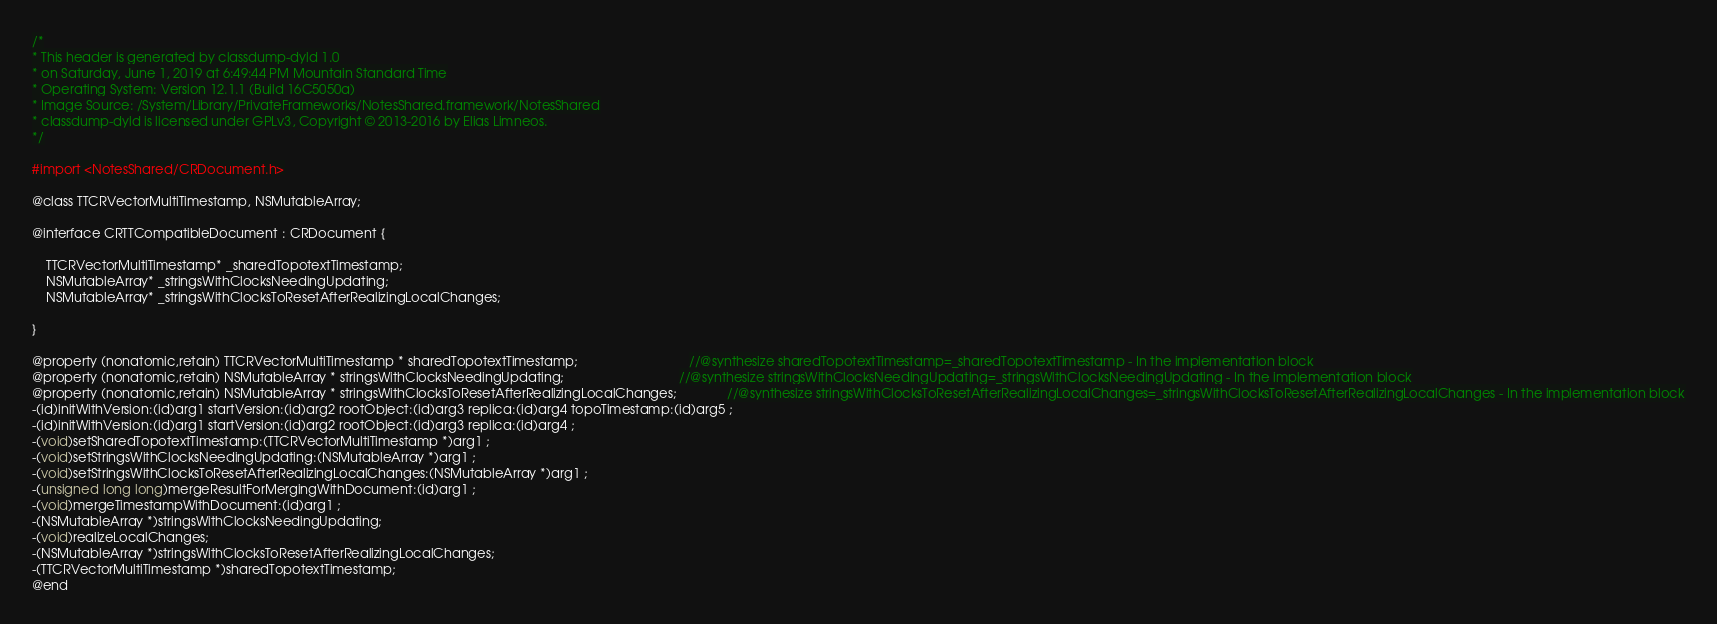Convert code to text. <code><loc_0><loc_0><loc_500><loc_500><_C_>/*
* This header is generated by classdump-dyld 1.0
* on Saturday, June 1, 2019 at 6:49:44 PM Mountain Standard Time
* Operating System: Version 12.1.1 (Build 16C5050a)
* Image Source: /System/Library/PrivateFrameworks/NotesShared.framework/NotesShared
* classdump-dyld is licensed under GPLv3, Copyright © 2013-2016 by Elias Limneos.
*/

#import <NotesShared/CRDocument.h>

@class TTCRVectorMultiTimestamp, NSMutableArray;

@interface CRTTCompatibleDocument : CRDocument {

	TTCRVectorMultiTimestamp* _sharedTopotextTimestamp;
	NSMutableArray* _stringsWithClocksNeedingUpdating;
	NSMutableArray* _stringsWithClocksToResetAfterRealizingLocalChanges;

}

@property (nonatomic,retain) TTCRVectorMultiTimestamp * sharedTopotextTimestamp;                               //@synthesize sharedTopotextTimestamp=_sharedTopotextTimestamp - In the implementation block
@property (nonatomic,retain) NSMutableArray * stringsWithClocksNeedingUpdating;                                //@synthesize stringsWithClocksNeedingUpdating=_stringsWithClocksNeedingUpdating - In the implementation block
@property (nonatomic,retain) NSMutableArray * stringsWithClocksToResetAfterRealizingLocalChanges;              //@synthesize stringsWithClocksToResetAfterRealizingLocalChanges=_stringsWithClocksToResetAfterRealizingLocalChanges - In the implementation block
-(id)initWithVersion:(id)arg1 startVersion:(id)arg2 rootObject:(id)arg3 replica:(id)arg4 topoTimestamp:(id)arg5 ;
-(id)initWithVersion:(id)arg1 startVersion:(id)arg2 rootObject:(id)arg3 replica:(id)arg4 ;
-(void)setSharedTopotextTimestamp:(TTCRVectorMultiTimestamp *)arg1 ;
-(void)setStringsWithClocksNeedingUpdating:(NSMutableArray *)arg1 ;
-(void)setStringsWithClocksToResetAfterRealizingLocalChanges:(NSMutableArray *)arg1 ;
-(unsigned long long)mergeResultForMergingWithDocument:(id)arg1 ;
-(void)mergeTimestampWithDocument:(id)arg1 ;
-(NSMutableArray *)stringsWithClocksNeedingUpdating;
-(void)realizeLocalChanges;
-(NSMutableArray *)stringsWithClocksToResetAfterRealizingLocalChanges;
-(TTCRVectorMultiTimestamp *)sharedTopotextTimestamp;
@end

</code> 